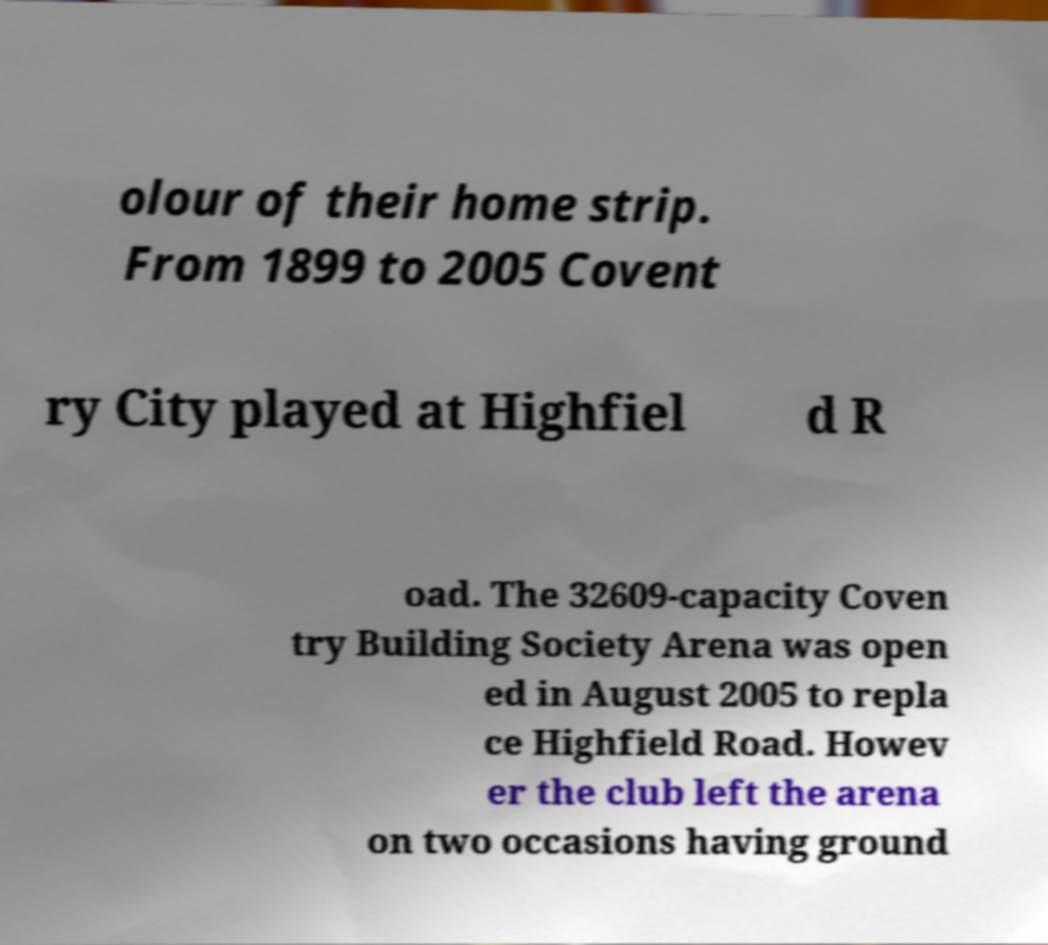I need the written content from this picture converted into text. Can you do that? olour of their home strip. From 1899 to 2005 Covent ry City played at Highfiel d R oad. The 32609-capacity Coven try Building Society Arena was open ed in August 2005 to repla ce Highfield Road. Howev er the club left the arena on two occasions having ground 